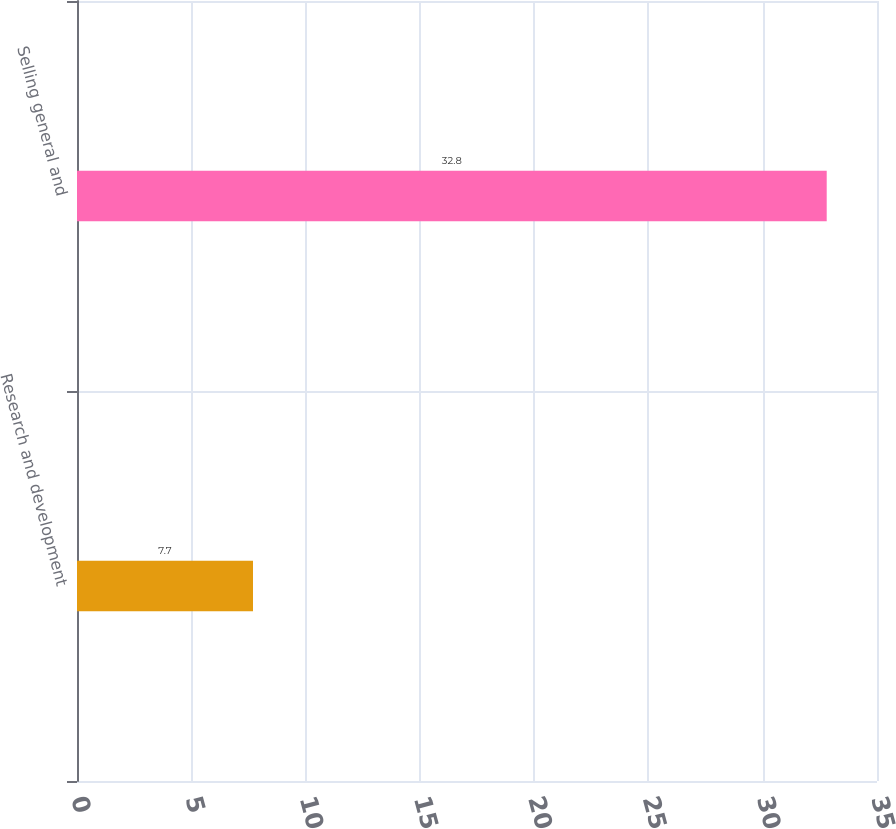Convert chart. <chart><loc_0><loc_0><loc_500><loc_500><bar_chart><fcel>Research and development<fcel>Selling general and<nl><fcel>7.7<fcel>32.8<nl></chart> 